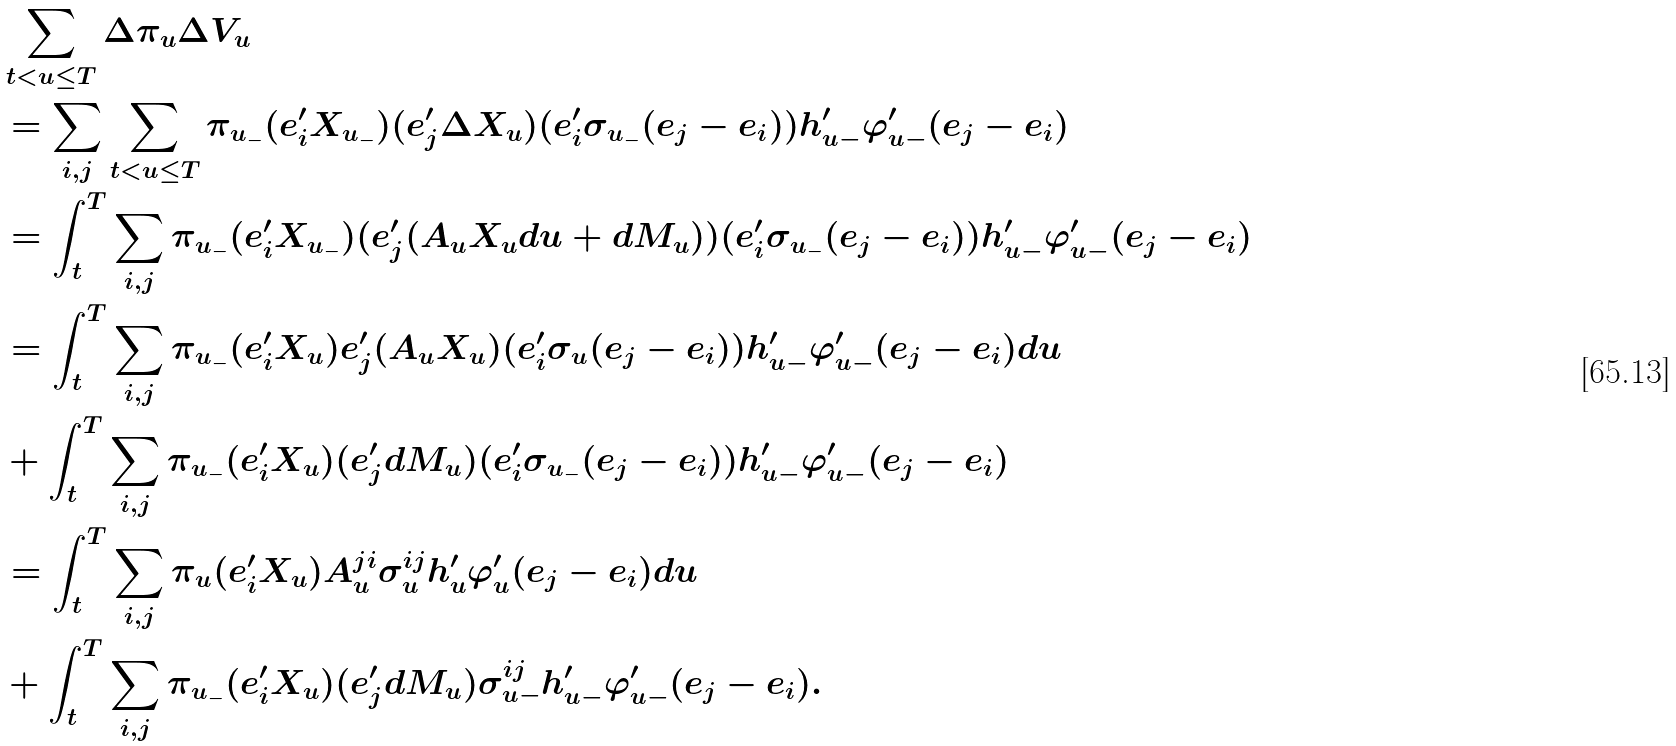<formula> <loc_0><loc_0><loc_500><loc_500>& \sum _ { t < u \leq T } \Delta \pi _ { u } \Delta V _ { u } \\ & = \sum _ { i , j } \sum _ { t < u \leq T } \pi _ { u _ { - } } ( e ^ { \prime } _ { i } X _ { u _ { - } } ) ( e ^ { \prime } _ { j } \Delta X _ { u } ) ( e ^ { \prime } _ { i } \sigma _ { u _ { - } } ( e _ { j } - e _ { i } ) ) h ^ { \prime } _ { u - } \varphi ^ { \prime } _ { u - } ( e _ { j } - e _ { i } ) \\ & = \int _ { t } ^ { T } \sum _ { i , j } \pi _ { u _ { - } } ( e ^ { \prime } _ { i } X _ { u _ { - } } ) ( e ^ { \prime } _ { j } ( A _ { u } X _ { u } d u + d M _ { u } ) ) ( e ^ { \prime } _ { i } \sigma _ { u _ { - } } ( e _ { j } - e _ { i } ) ) h ^ { \prime } _ { u - } \varphi ^ { \prime } _ { u - } ( e _ { j } - e _ { i } ) \\ & = \int _ { t } ^ { T } \sum _ { i , j } \pi _ { u _ { - } } ( e ^ { \prime } _ { i } X _ { u } ) e ^ { \prime } _ { j } ( A _ { u } X _ { u } ) ( e ^ { \prime } _ { i } \sigma _ { u } ( e _ { j } - e _ { i } ) ) h ^ { \prime } _ { u - } \varphi ^ { \prime } _ { u - } ( e _ { j } - e _ { i } ) d u \\ & + \int _ { t } ^ { T } \sum _ { i , j } \pi _ { u _ { - } } ( e ^ { \prime } _ { i } X _ { u } ) ( e ^ { \prime } _ { j } d M _ { u } ) ( e ^ { \prime } _ { i } \sigma _ { u _ { - } } ( e _ { j } - e _ { i } ) ) h ^ { \prime } _ { u - } \varphi ^ { \prime } _ { u - } ( e _ { j } - e _ { i } ) \\ & = \int _ { t } ^ { T } \sum _ { i , j } \pi _ { u } ( e ^ { \prime } _ { i } X _ { u } ) A _ { u } ^ { j i } \sigma _ { u } ^ { i j } h ^ { \prime } _ { u } \varphi ^ { \prime } _ { u } ( e _ { j } - e _ { i } ) d u \\ & + \int _ { t } ^ { T } \sum _ { i , j } \pi _ { u _ { - } } ( e ^ { \prime } _ { i } X _ { u } ) ( e ^ { \prime } _ { j } d M _ { u } ) \sigma _ { u - } ^ { i j } h ^ { \prime } _ { u - } \varphi ^ { \prime } _ { u - } ( e _ { j } - e _ { i } ) .</formula> 